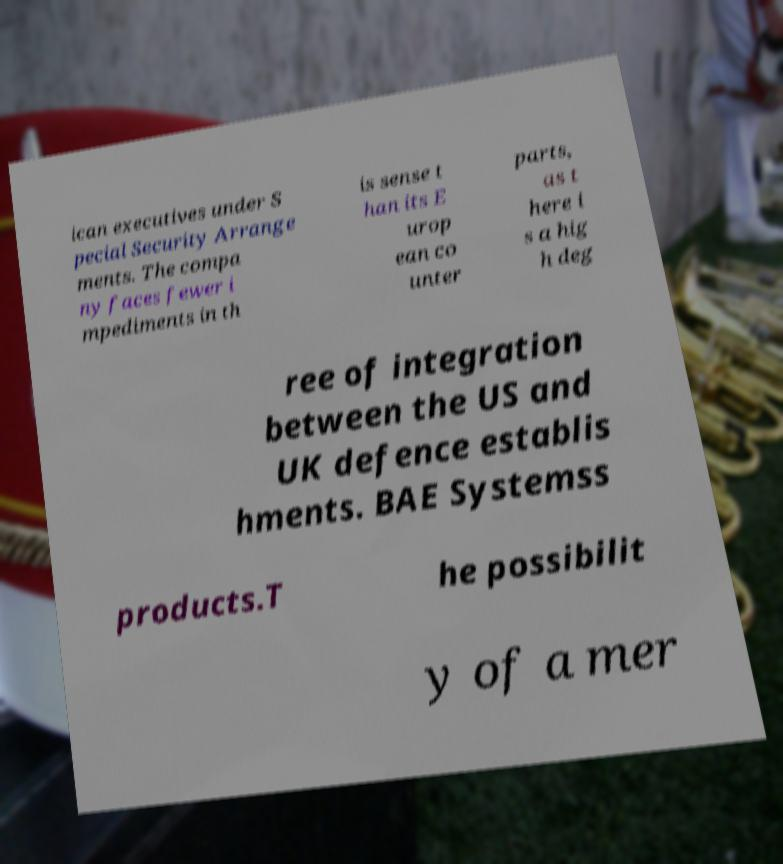There's text embedded in this image that I need extracted. Can you transcribe it verbatim? ican executives under S pecial Security Arrange ments. The compa ny faces fewer i mpediments in th is sense t han its E urop ean co unter parts, as t here i s a hig h deg ree of integration between the US and UK defence establis hments. BAE Systemss products.T he possibilit y of a mer 